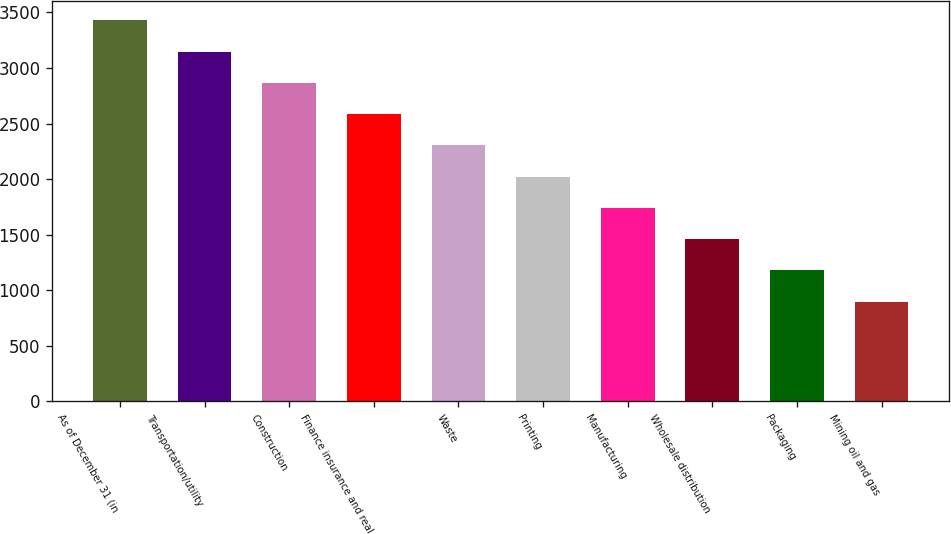Convert chart to OTSL. <chart><loc_0><loc_0><loc_500><loc_500><bar_chart><fcel>As of December 31 (in<fcel>Transportation/utility<fcel>Construction<fcel>Finance insurance and real<fcel>Waste<fcel>Printing<fcel>Manufacturing<fcel>Wholesale distribution<fcel>Packaging<fcel>Mining oil and gas<nl><fcel>3428.22<fcel>3146.86<fcel>2865.5<fcel>2584.14<fcel>2302.78<fcel>2021.42<fcel>1740.06<fcel>1458.7<fcel>1177.34<fcel>895.98<nl></chart> 